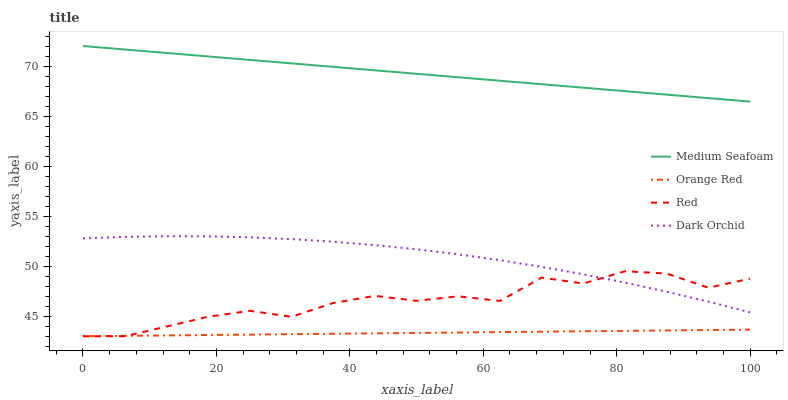Does Orange Red have the minimum area under the curve?
Answer yes or no. Yes. Does Medium Seafoam have the maximum area under the curve?
Answer yes or no. Yes. Does Red have the minimum area under the curve?
Answer yes or no. No. Does Red have the maximum area under the curve?
Answer yes or no. No. Is Orange Red the smoothest?
Answer yes or no. Yes. Is Red the roughest?
Answer yes or no. Yes. Is Medium Seafoam the smoothest?
Answer yes or no. No. Is Medium Seafoam the roughest?
Answer yes or no. No. Does Red have the lowest value?
Answer yes or no. Yes. Does Medium Seafoam have the lowest value?
Answer yes or no. No. Does Medium Seafoam have the highest value?
Answer yes or no. Yes. Does Red have the highest value?
Answer yes or no. No. Is Red less than Medium Seafoam?
Answer yes or no. Yes. Is Medium Seafoam greater than Orange Red?
Answer yes or no. Yes. Does Red intersect Dark Orchid?
Answer yes or no. Yes. Is Red less than Dark Orchid?
Answer yes or no. No. Is Red greater than Dark Orchid?
Answer yes or no. No. Does Red intersect Medium Seafoam?
Answer yes or no. No. 